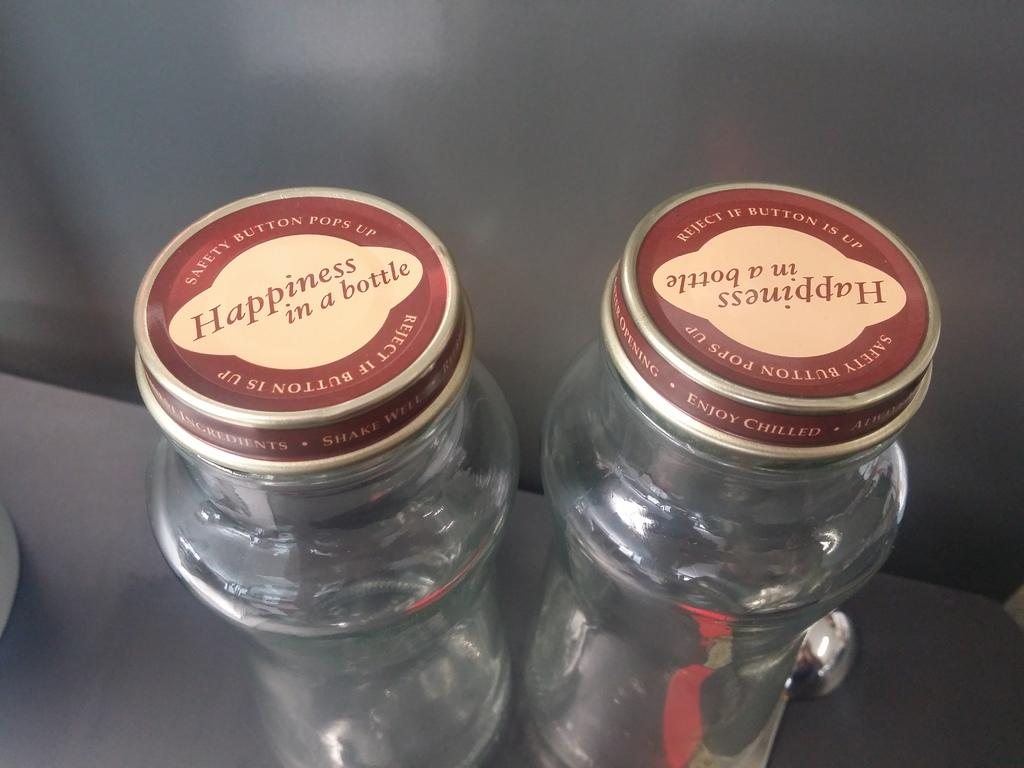Provide a one-sentence caption for the provided image. Two empty glass bottles say "Happiness in a bottle" on top. 